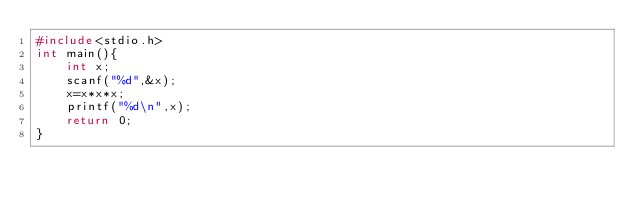Convert code to text. <code><loc_0><loc_0><loc_500><loc_500><_C_>#include<stdio.h>
int main(){
    int x;
    scanf("%d",&x);
    x=x*x*x;
    printf("%d\n",x);
    return 0;
}
</code> 